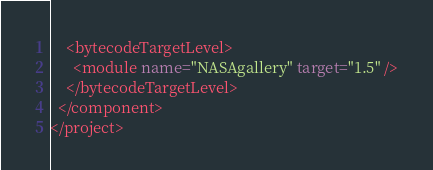<code> <loc_0><loc_0><loc_500><loc_500><_XML_>    <bytecodeTargetLevel>
      <module name="NASAgallery" target="1.5" />
    </bytecodeTargetLevel>
  </component>
</project></code> 